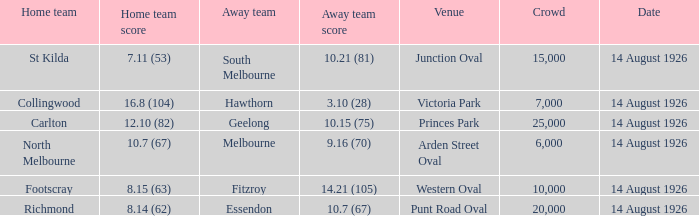10 (28)? 7000.0. Parse the full table. {'header': ['Home team', 'Home team score', 'Away team', 'Away team score', 'Venue', 'Crowd', 'Date'], 'rows': [['St Kilda', '7.11 (53)', 'South Melbourne', '10.21 (81)', 'Junction Oval', '15,000', '14 August 1926'], ['Collingwood', '16.8 (104)', 'Hawthorn', '3.10 (28)', 'Victoria Park', '7,000', '14 August 1926'], ['Carlton', '12.10 (82)', 'Geelong', '10.15 (75)', 'Princes Park', '25,000', '14 August 1926'], ['North Melbourne', '10.7 (67)', 'Melbourne', '9.16 (70)', 'Arden Street Oval', '6,000', '14 August 1926'], ['Footscray', '8.15 (63)', 'Fitzroy', '14.21 (105)', 'Western Oval', '10,000', '14 August 1926'], ['Richmond', '8.14 (62)', 'Essendon', '10.7 (67)', 'Punt Road Oval', '20,000', '14 August 1926']]} 